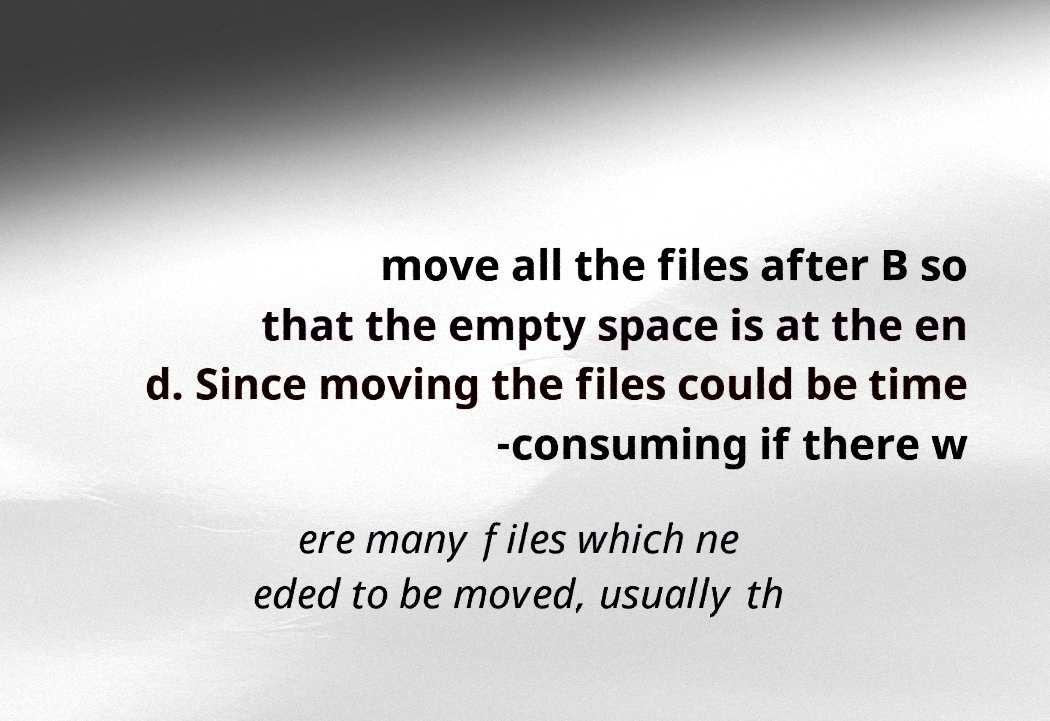Can you read and provide the text displayed in the image?This photo seems to have some interesting text. Can you extract and type it out for me? move all the files after B so that the empty space is at the en d. Since moving the files could be time -consuming if there w ere many files which ne eded to be moved, usually th 